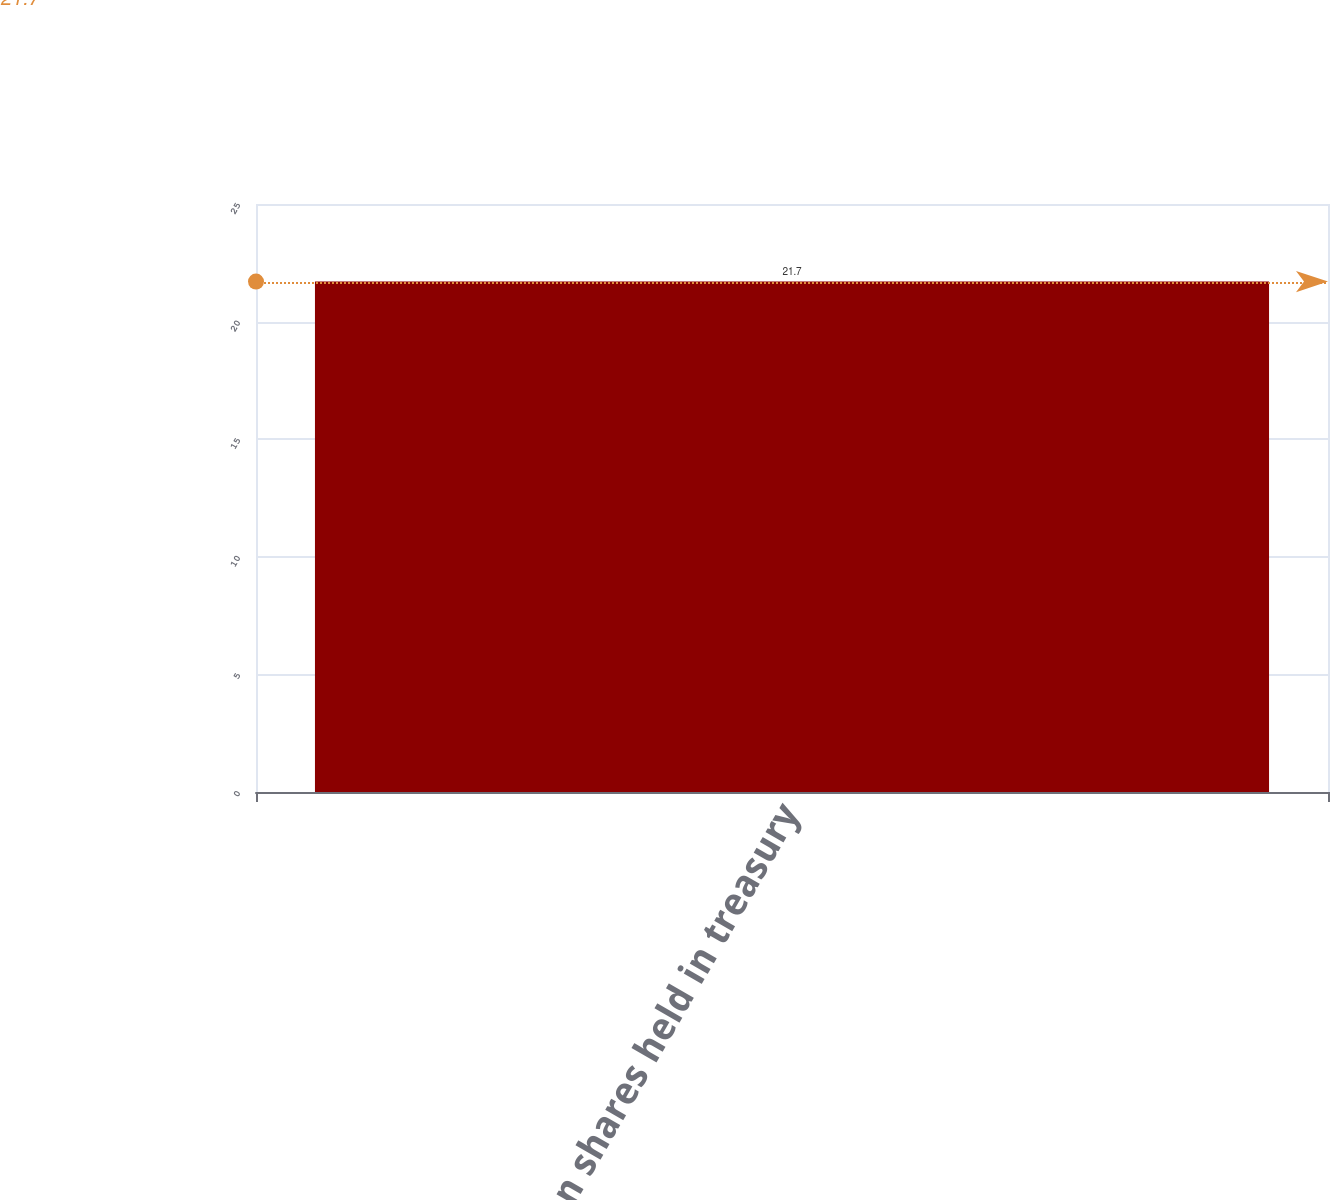Convert chart. <chart><loc_0><loc_0><loc_500><loc_500><bar_chart><fcel>Common shares held in treasury<nl><fcel>21.7<nl></chart> 